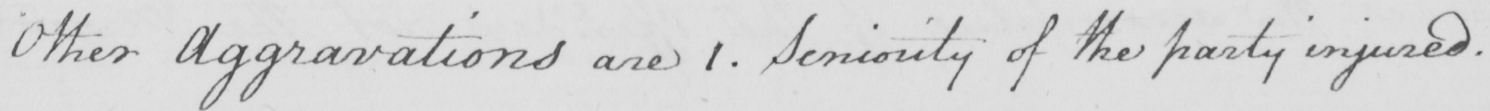What text is written in this handwritten line? Other Aggravations are 1 . Seniority of the party injured . 